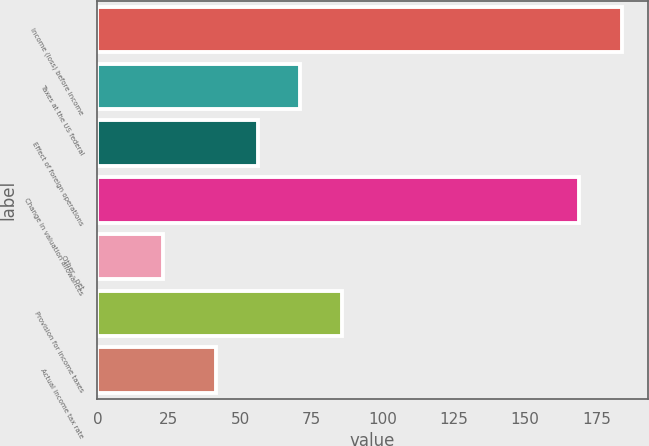Convert chart. <chart><loc_0><loc_0><loc_500><loc_500><bar_chart><fcel>Income (loss) before income<fcel>Taxes at the US federal<fcel>Effect of foreign operations<fcel>Change in valuation allowances<fcel>Other - net<fcel>Provision for income taxes<fcel>Actual income tax rate<nl><fcel>183.8<fcel>71.1<fcel>56.3<fcel>169<fcel>23<fcel>85.9<fcel>41.5<nl></chart> 